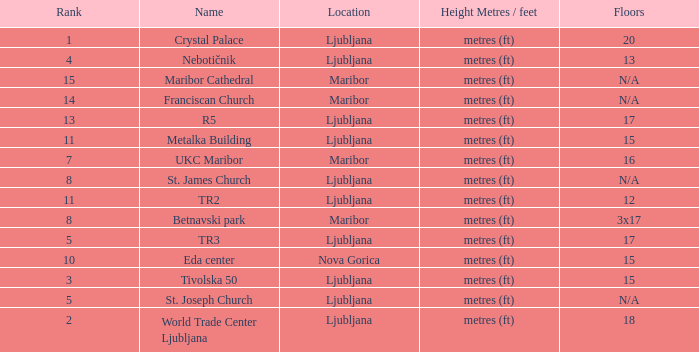Which Floors have a Location of ljubljana, and a Name of tr3? 17.0. 